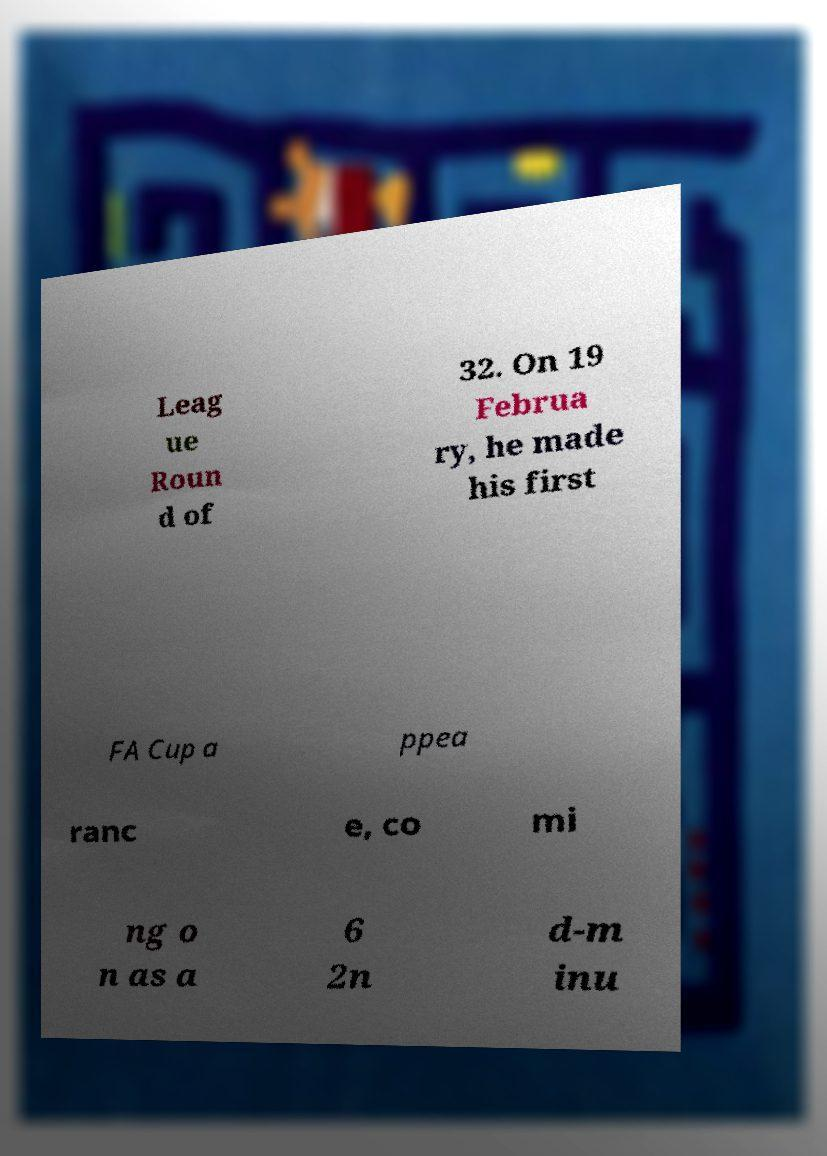Please read and relay the text visible in this image. What does it say? Leag ue Roun d of 32. On 19 Februa ry, he made his first FA Cup a ppea ranc e, co mi ng o n as a 6 2n d-m inu 